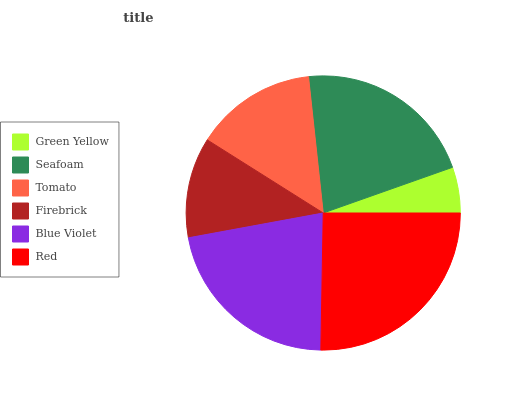Is Green Yellow the minimum?
Answer yes or no. Yes. Is Red the maximum?
Answer yes or no. Yes. Is Seafoam the minimum?
Answer yes or no. No. Is Seafoam the maximum?
Answer yes or no. No. Is Seafoam greater than Green Yellow?
Answer yes or no. Yes. Is Green Yellow less than Seafoam?
Answer yes or no. Yes. Is Green Yellow greater than Seafoam?
Answer yes or no. No. Is Seafoam less than Green Yellow?
Answer yes or no. No. Is Seafoam the high median?
Answer yes or no. Yes. Is Tomato the low median?
Answer yes or no. Yes. Is Firebrick the high median?
Answer yes or no. No. Is Red the low median?
Answer yes or no. No. 